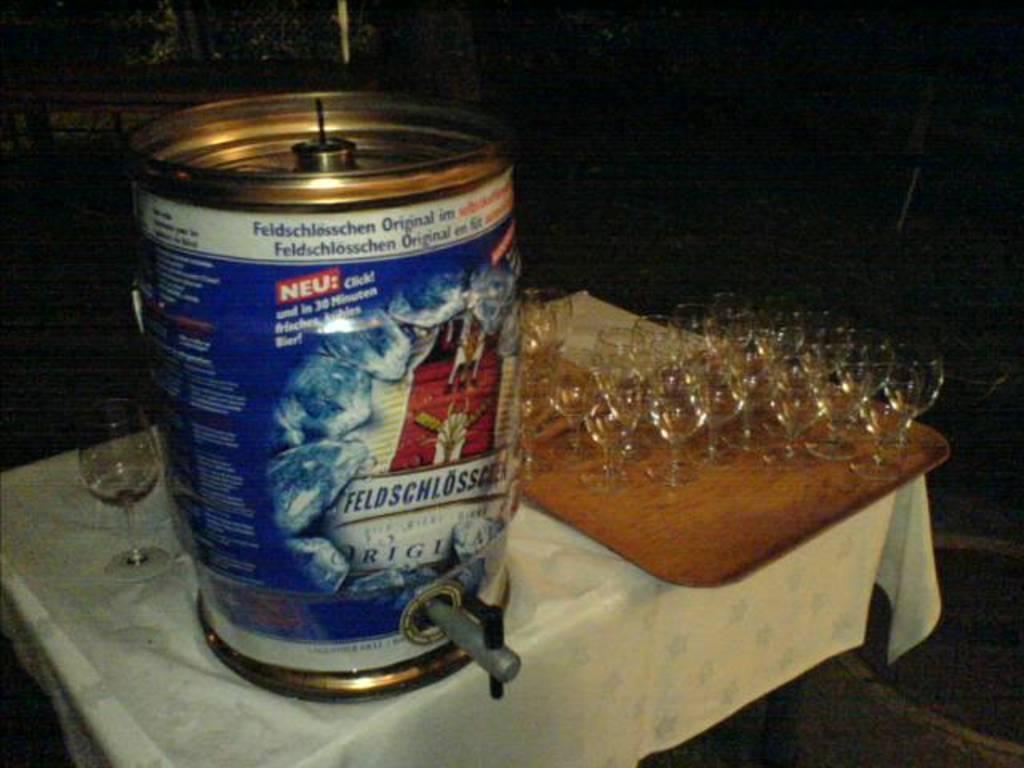Please provide a concise description of this image. In this image it looks like a can on the table. I can also see the glasses on the tray. 